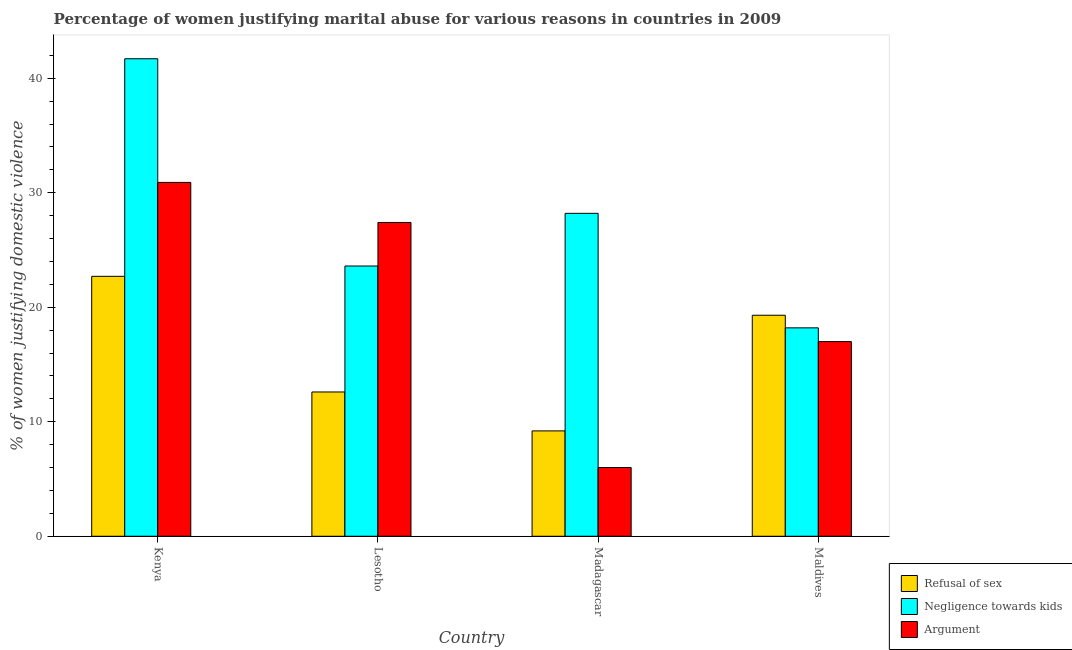How many groups of bars are there?
Provide a succinct answer. 4. How many bars are there on the 3rd tick from the left?
Make the answer very short. 3. What is the label of the 4th group of bars from the left?
Offer a very short reply. Maldives. In how many cases, is the number of bars for a given country not equal to the number of legend labels?
Your answer should be compact. 0. What is the percentage of women justifying domestic violence due to negligence towards kids in Madagascar?
Make the answer very short. 28.2. Across all countries, what is the maximum percentage of women justifying domestic violence due to arguments?
Your answer should be compact. 30.9. In which country was the percentage of women justifying domestic violence due to arguments maximum?
Offer a terse response. Kenya. In which country was the percentage of women justifying domestic violence due to negligence towards kids minimum?
Provide a succinct answer. Maldives. What is the total percentage of women justifying domestic violence due to refusal of sex in the graph?
Offer a very short reply. 63.8. What is the difference between the percentage of women justifying domestic violence due to negligence towards kids in Lesotho and that in Madagascar?
Provide a short and direct response. -4.6. What is the difference between the percentage of women justifying domestic violence due to refusal of sex in Maldives and the percentage of women justifying domestic violence due to negligence towards kids in Madagascar?
Provide a succinct answer. -8.9. What is the average percentage of women justifying domestic violence due to refusal of sex per country?
Provide a short and direct response. 15.95. What is the difference between the percentage of women justifying domestic violence due to negligence towards kids and percentage of women justifying domestic violence due to refusal of sex in Lesotho?
Offer a terse response. 11. In how many countries, is the percentage of women justifying domestic violence due to refusal of sex greater than 24 %?
Your answer should be compact. 0. What is the ratio of the percentage of women justifying domestic violence due to negligence towards kids in Madagascar to that in Maldives?
Provide a short and direct response. 1.55. Is the difference between the percentage of women justifying domestic violence due to negligence towards kids in Lesotho and Maldives greater than the difference between the percentage of women justifying domestic violence due to refusal of sex in Lesotho and Maldives?
Ensure brevity in your answer.  Yes. What is the difference between the highest and the second highest percentage of women justifying domestic violence due to negligence towards kids?
Your answer should be compact. 13.5. What is the difference between the highest and the lowest percentage of women justifying domestic violence due to negligence towards kids?
Provide a succinct answer. 23.5. In how many countries, is the percentage of women justifying domestic violence due to arguments greater than the average percentage of women justifying domestic violence due to arguments taken over all countries?
Offer a very short reply. 2. What does the 2nd bar from the left in Madagascar represents?
Make the answer very short. Negligence towards kids. What does the 1st bar from the right in Lesotho represents?
Provide a short and direct response. Argument. What is the difference between two consecutive major ticks on the Y-axis?
Ensure brevity in your answer.  10. Does the graph contain any zero values?
Your response must be concise. No. Where does the legend appear in the graph?
Provide a short and direct response. Bottom right. What is the title of the graph?
Provide a short and direct response. Percentage of women justifying marital abuse for various reasons in countries in 2009. What is the label or title of the X-axis?
Your response must be concise. Country. What is the label or title of the Y-axis?
Keep it short and to the point. % of women justifying domestic violence. What is the % of women justifying domestic violence of Refusal of sex in Kenya?
Offer a terse response. 22.7. What is the % of women justifying domestic violence of Negligence towards kids in Kenya?
Your response must be concise. 41.7. What is the % of women justifying domestic violence in Argument in Kenya?
Offer a terse response. 30.9. What is the % of women justifying domestic violence of Negligence towards kids in Lesotho?
Your answer should be compact. 23.6. What is the % of women justifying domestic violence in Argument in Lesotho?
Provide a succinct answer. 27.4. What is the % of women justifying domestic violence of Refusal of sex in Madagascar?
Offer a terse response. 9.2. What is the % of women justifying domestic violence of Negligence towards kids in Madagascar?
Your response must be concise. 28.2. What is the % of women justifying domestic violence in Argument in Madagascar?
Offer a very short reply. 6. What is the % of women justifying domestic violence of Refusal of sex in Maldives?
Keep it short and to the point. 19.3. What is the % of women justifying domestic violence in Negligence towards kids in Maldives?
Keep it short and to the point. 18.2. Across all countries, what is the maximum % of women justifying domestic violence in Refusal of sex?
Make the answer very short. 22.7. Across all countries, what is the maximum % of women justifying domestic violence in Negligence towards kids?
Your answer should be very brief. 41.7. Across all countries, what is the maximum % of women justifying domestic violence of Argument?
Your answer should be compact. 30.9. Across all countries, what is the minimum % of women justifying domestic violence in Refusal of sex?
Provide a short and direct response. 9.2. Across all countries, what is the minimum % of women justifying domestic violence of Argument?
Give a very brief answer. 6. What is the total % of women justifying domestic violence in Refusal of sex in the graph?
Your answer should be compact. 63.8. What is the total % of women justifying domestic violence of Negligence towards kids in the graph?
Offer a terse response. 111.7. What is the total % of women justifying domestic violence of Argument in the graph?
Provide a succinct answer. 81.3. What is the difference between the % of women justifying domestic violence of Negligence towards kids in Kenya and that in Lesotho?
Offer a terse response. 18.1. What is the difference between the % of women justifying domestic violence of Argument in Kenya and that in Lesotho?
Keep it short and to the point. 3.5. What is the difference between the % of women justifying domestic violence in Negligence towards kids in Kenya and that in Madagascar?
Provide a short and direct response. 13.5. What is the difference between the % of women justifying domestic violence of Argument in Kenya and that in Madagascar?
Keep it short and to the point. 24.9. What is the difference between the % of women justifying domestic violence of Refusal of sex in Kenya and that in Maldives?
Keep it short and to the point. 3.4. What is the difference between the % of women justifying domestic violence of Negligence towards kids in Kenya and that in Maldives?
Provide a short and direct response. 23.5. What is the difference between the % of women justifying domestic violence in Argument in Lesotho and that in Madagascar?
Your answer should be very brief. 21.4. What is the difference between the % of women justifying domestic violence in Negligence towards kids in Lesotho and that in Maldives?
Offer a terse response. 5.4. What is the difference between the % of women justifying domestic violence of Argument in Lesotho and that in Maldives?
Your answer should be very brief. 10.4. What is the difference between the % of women justifying domestic violence of Refusal of sex in Madagascar and that in Maldives?
Ensure brevity in your answer.  -10.1. What is the difference between the % of women justifying domestic violence of Argument in Madagascar and that in Maldives?
Make the answer very short. -11. What is the difference between the % of women justifying domestic violence of Refusal of sex in Kenya and the % of women justifying domestic violence of Negligence towards kids in Lesotho?
Provide a short and direct response. -0.9. What is the difference between the % of women justifying domestic violence of Negligence towards kids in Kenya and the % of women justifying domestic violence of Argument in Lesotho?
Keep it short and to the point. 14.3. What is the difference between the % of women justifying domestic violence of Refusal of sex in Kenya and the % of women justifying domestic violence of Negligence towards kids in Madagascar?
Make the answer very short. -5.5. What is the difference between the % of women justifying domestic violence of Negligence towards kids in Kenya and the % of women justifying domestic violence of Argument in Madagascar?
Your answer should be very brief. 35.7. What is the difference between the % of women justifying domestic violence in Refusal of sex in Kenya and the % of women justifying domestic violence in Negligence towards kids in Maldives?
Your answer should be very brief. 4.5. What is the difference between the % of women justifying domestic violence of Negligence towards kids in Kenya and the % of women justifying domestic violence of Argument in Maldives?
Give a very brief answer. 24.7. What is the difference between the % of women justifying domestic violence in Refusal of sex in Lesotho and the % of women justifying domestic violence in Negligence towards kids in Madagascar?
Offer a terse response. -15.6. What is the difference between the % of women justifying domestic violence of Refusal of sex in Lesotho and the % of women justifying domestic violence of Argument in Madagascar?
Your answer should be compact. 6.6. What is the difference between the % of women justifying domestic violence of Refusal of sex in Lesotho and the % of women justifying domestic violence of Negligence towards kids in Maldives?
Provide a short and direct response. -5.6. What is the difference between the % of women justifying domestic violence in Refusal of sex in Lesotho and the % of women justifying domestic violence in Argument in Maldives?
Your answer should be compact. -4.4. What is the average % of women justifying domestic violence in Refusal of sex per country?
Give a very brief answer. 15.95. What is the average % of women justifying domestic violence of Negligence towards kids per country?
Offer a very short reply. 27.93. What is the average % of women justifying domestic violence in Argument per country?
Offer a terse response. 20.32. What is the difference between the % of women justifying domestic violence in Negligence towards kids and % of women justifying domestic violence in Argument in Kenya?
Your response must be concise. 10.8. What is the difference between the % of women justifying domestic violence of Refusal of sex and % of women justifying domestic violence of Negligence towards kids in Lesotho?
Keep it short and to the point. -11. What is the difference between the % of women justifying domestic violence of Refusal of sex and % of women justifying domestic violence of Argument in Lesotho?
Offer a terse response. -14.8. What is the difference between the % of women justifying domestic violence of Refusal of sex and % of women justifying domestic violence of Negligence towards kids in Madagascar?
Your answer should be compact. -19. What is the difference between the % of women justifying domestic violence in Refusal of sex and % of women justifying domestic violence in Argument in Maldives?
Your answer should be compact. 2.3. What is the ratio of the % of women justifying domestic violence in Refusal of sex in Kenya to that in Lesotho?
Provide a short and direct response. 1.8. What is the ratio of the % of women justifying domestic violence in Negligence towards kids in Kenya to that in Lesotho?
Your answer should be compact. 1.77. What is the ratio of the % of women justifying domestic violence of Argument in Kenya to that in Lesotho?
Make the answer very short. 1.13. What is the ratio of the % of women justifying domestic violence in Refusal of sex in Kenya to that in Madagascar?
Give a very brief answer. 2.47. What is the ratio of the % of women justifying domestic violence in Negligence towards kids in Kenya to that in Madagascar?
Keep it short and to the point. 1.48. What is the ratio of the % of women justifying domestic violence of Argument in Kenya to that in Madagascar?
Ensure brevity in your answer.  5.15. What is the ratio of the % of women justifying domestic violence of Refusal of sex in Kenya to that in Maldives?
Your answer should be compact. 1.18. What is the ratio of the % of women justifying domestic violence in Negligence towards kids in Kenya to that in Maldives?
Give a very brief answer. 2.29. What is the ratio of the % of women justifying domestic violence of Argument in Kenya to that in Maldives?
Make the answer very short. 1.82. What is the ratio of the % of women justifying domestic violence in Refusal of sex in Lesotho to that in Madagascar?
Make the answer very short. 1.37. What is the ratio of the % of women justifying domestic violence in Negligence towards kids in Lesotho to that in Madagascar?
Provide a succinct answer. 0.84. What is the ratio of the % of women justifying domestic violence of Argument in Lesotho to that in Madagascar?
Give a very brief answer. 4.57. What is the ratio of the % of women justifying domestic violence in Refusal of sex in Lesotho to that in Maldives?
Keep it short and to the point. 0.65. What is the ratio of the % of women justifying domestic violence in Negligence towards kids in Lesotho to that in Maldives?
Offer a terse response. 1.3. What is the ratio of the % of women justifying domestic violence of Argument in Lesotho to that in Maldives?
Keep it short and to the point. 1.61. What is the ratio of the % of women justifying domestic violence of Refusal of sex in Madagascar to that in Maldives?
Make the answer very short. 0.48. What is the ratio of the % of women justifying domestic violence in Negligence towards kids in Madagascar to that in Maldives?
Offer a terse response. 1.55. What is the ratio of the % of women justifying domestic violence of Argument in Madagascar to that in Maldives?
Provide a short and direct response. 0.35. What is the difference between the highest and the second highest % of women justifying domestic violence of Argument?
Offer a very short reply. 3.5. What is the difference between the highest and the lowest % of women justifying domestic violence of Argument?
Give a very brief answer. 24.9. 